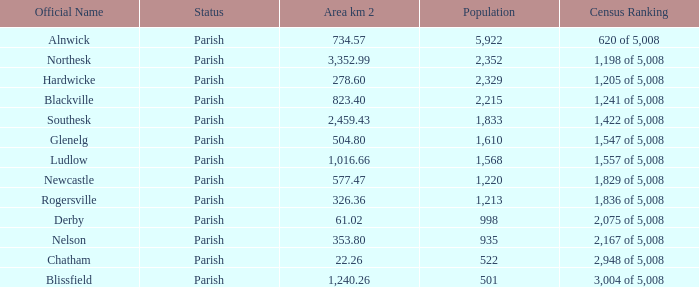Can you disclose the combined area km 2 designated with the official name of glenelg? 504.8. 